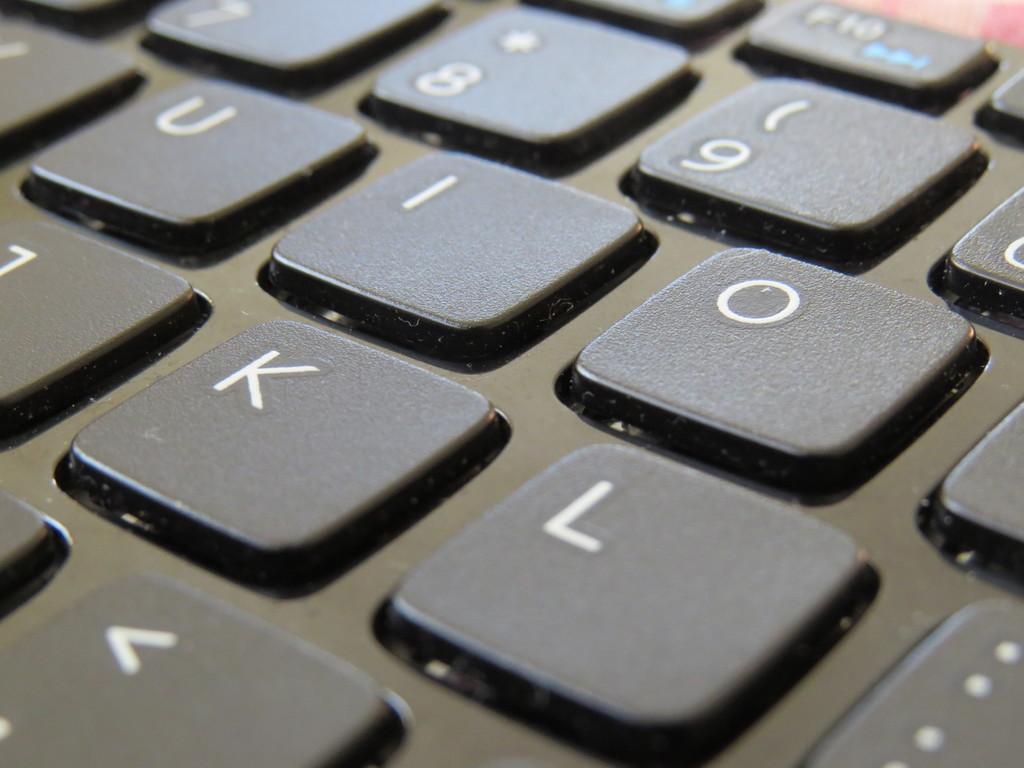What are the letter keys here?
Offer a very short reply. Uiokl. 